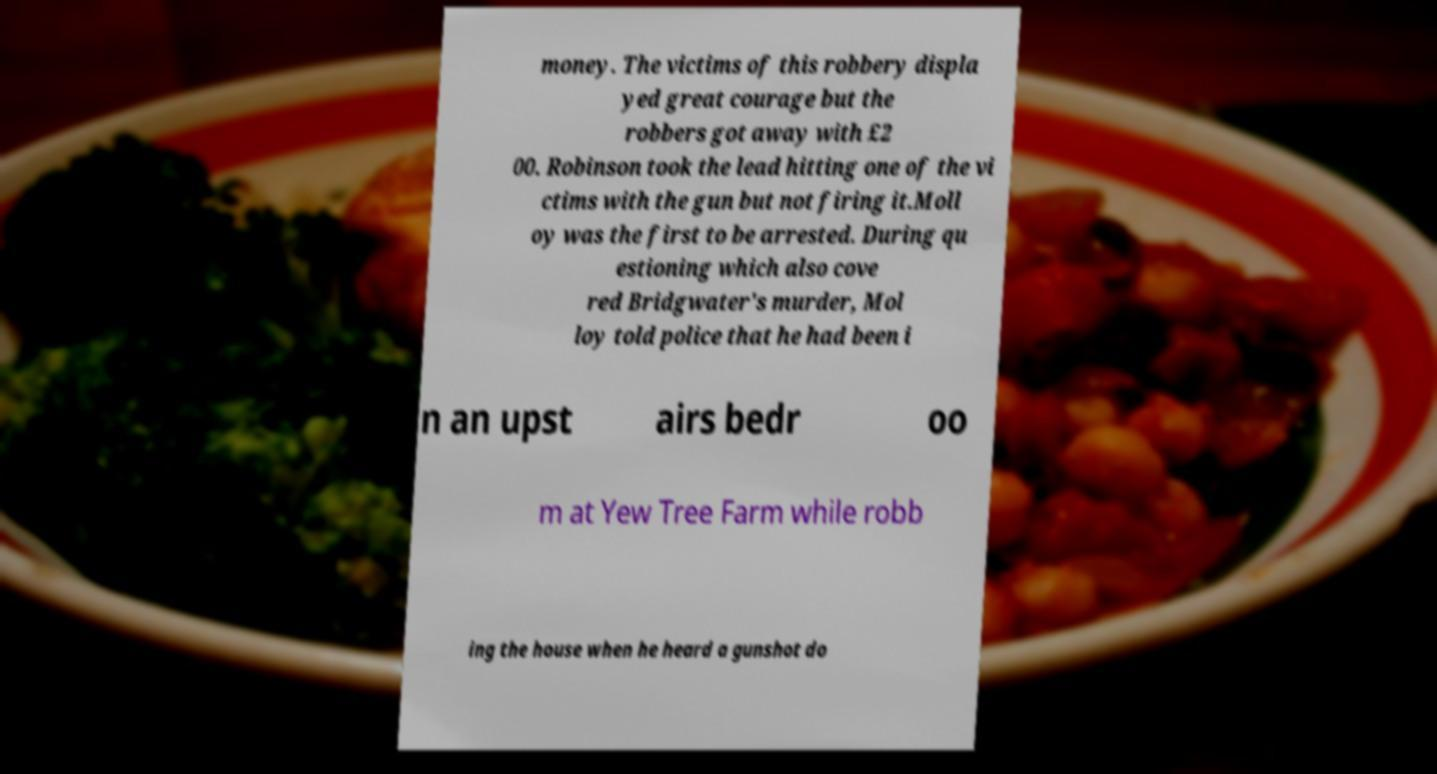I need the written content from this picture converted into text. Can you do that? money. The victims of this robbery displa yed great courage but the robbers got away with £2 00. Robinson took the lead hitting one of the vi ctims with the gun but not firing it.Moll oy was the first to be arrested. During qu estioning which also cove red Bridgwater's murder, Mol loy told police that he had been i n an upst airs bedr oo m at Yew Tree Farm while robb ing the house when he heard a gunshot do 